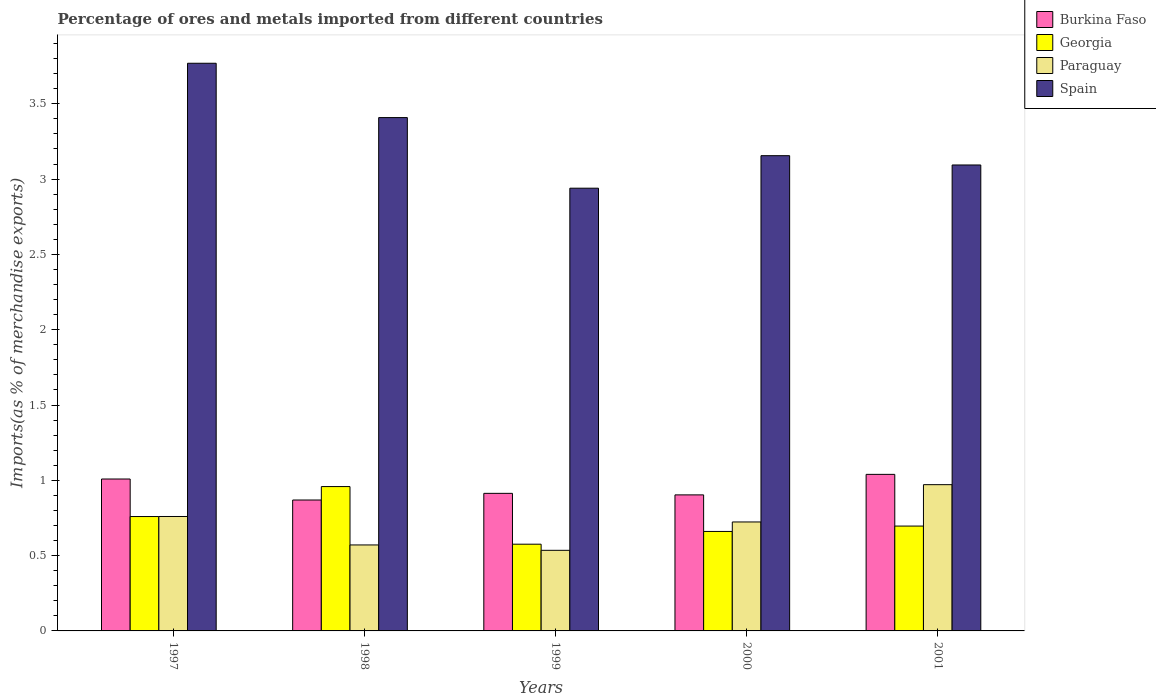How many different coloured bars are there?
Make the answer very short. 4. Are the number of bars per tick equal to the number of legend labels?
Keep it short and to the point. Yes. Are the number of bars on each tick of the X-axis equal?
Make the answer very short. Yes. How many bars are there on the 1st tick from the left?
Keep it short and to the point. 4. What is the label of the 4th group of bars from the left?
Your answer should be compact. 2000. In how many cases, is the number of bars for a given year not equal to the number of legend labels?
Provide a short and direct response. 0. What is the percentage of imports to different countries in Georgia in 1999?
Offer a very short reply. 0.58. Across all years, what is the maximum percentage of imports to different countries in Spain?
Ensure brevity in your answer.  3.77. Across all years, what is the minimum percentage of imports to different countries in Georgia?
Offer a very short reply. 0.58. In which year was the percentage of imports to different countries in Georgia maximum?
Make the answer very short. 1998. What is the total percentage of imports to different countries in Burkina Faso in the graph?
Ensure brevity in your answer.  4.73. What is the difference between the percentage of imports to different countries in Spain in 1998 and that in 2001?
Your response must be concise. 0.31. What is the difference between the percentage of imports to different countries in Burkina Faso in 1998 and the percentage of imports to different countries in Georgia in 2001?
Provide a succinct answer. 0.17. What is the average percentage of imports to different countries in Burkina Faso per year?
Your answer should be very brief. 0.95. In the year 1998, what is the difference between the percentage of imports to different countries in Georgia and percentage of imports to different countries in Paraguay?
Your response must be concise. 0.39. In how many years, is the percentage of imports to different countries in Spain greater than 1.2 %?
Your answer should be compact. 5. What is the ratio of the percentage of imports to different countries in Burkina Faso in 1999 to that in 2001?
Keep it short and to the point. 0.88. Is the percentage of imports to different countries in Paraguay in 1998 less than that in 2001?
Provide a short and direct response. Yes. Is the difference between the percentage of imports to different countries in Georgia in 1997 and 2000 greater than the difference between the percentage of imports to different countries in Paraguay in 1997 and 2000?
Ensure brevity in your answer.  Yes. What is the difference between the highest and the second highest percentage of imports to different countries in Spain?
Ensure brevity in your answer.  0.36. What is the difference between the highest and the lowest percentage of imports to different countries in Spain?
Make the answer very short. 0.83. In how many years, is the percentage of imports to different countries in Paraguay greater than the average percentage of imports to different countries in Paraguay taken over all years?
Keep it short and to the point. 3. Is it the case that in every year, the sum of the percentage of imports to different countries in Spain and percentage of imports to different countries in Georgia is greater than the sum of percentage of imports to different countries in Burkina Faso and percentage of imports to different countries in Paraguay?
Offer a very short reply. Yes. What does the 2nd bar from the left in 1997 represents?
Provide a short and direct response. Georgia. What does the 1st bar from the right in 1998 represents?
Your response must be concise. Spain. What is the difference between two consecutive major ticks on the Y-axis?
Provide a short and direct response. 0.5. Are the values on the major ticks of Y-axis written in scientific E-notation?
Offer a terse response. No. What is the title of the graph?
Give a very brief answer. Percentage of ores and metals imported from different countries. Does "Qatar" appear as one of the legend labels in the graph?
Provide a short and direct response. No. What is the label or title of the Y-axis?
Make the answer very short. Imports(as % of merchandise exports). What is the Imports(as % of merchandise exports) of Burkina Faso in 1997?
Your answer should be compact. 1.01. What is the Imports(as % of merchandise exports) of Georgia in 1997?
Give a very brief answer. 0.76. What is the Imports(as % of merchandise exports) in Paraguay in 1997?
Provide a succinct answer. 0.76. What is the Imports(as % of merchandise exports) in Spain in 1997?
Your response must be concise. 3.77. What is the Imports(as % of merchandise exports) in Burkina Faso in 1998?
Your response must be concise. 0.87. What is the Imports(as % of merchandise exports) in Georgia in 1998?
Your answer should be compact. 0.96. What is the Imports(as % of merchandise exports) of Paraguay in 1998?
Offer a very short reply. 0.57. What is the Imports(as % of merchandise exports) of Spain in 1998?
Ensure brevity in your answer.  3.41. What is the Imports(as % of merchandise exports) in Burkina Faso in 1999?
Your answer should be compact. 0.91. What is the Imports(as % of merchandise exports) in Georgia in 1999?
Keep it short and to the point. 0.58. What is the Imports(as % of merchandise exports) in Paraguay in 1999?
Provide a succinct answer. 0.54. What is the Imports(as % of merchandise exports) in Spain in 1999?
Your answer should be compact. 2.94. What is the Imports(as % of merchandise exports) of Burkina Faso in 2000?
Offer a very short reply. 0.9. What is the Imports(as % of merchandise exports) of Georgia in 2000?
Make the answer very short. 0.66. What is the Imports(as % of merchandise exports) in Paraguay in 2000?
Provide a succinct answer. 0.72. What is the Imports(as % of merchandise exports) in Spain in 2000?
Make the answer very short. 3.16. What is the Imports(as % of merchandise exports) of Burkina Faso in 2001?
Give a very brief answer. 1.04. What is the Imports(as % of merchandise exports) of Georgia in 2001?
Give a very brief answer. 0.7. What is the Imports(as % of merchandise exports) of Paraguay in 2001?
Provide a short and direct response. 0.97. What is the Imports(as % of merchandise exports) in Spain in 2001?
Your answer should be very brief. 3.09. Across all years, what is the maximum Imports(as % of merchandise exports) in Burkina Faso?
Offer a very short reply. 1.04. Across all years, what is the maximum Imports(as % of merchandise exports) of Georgia?
Provide a short and direct response. 0.96. Across all years, what is the maximum Imports(as % of merchandise exports) of Paraguay?
Give a very brief answer. 0.97. Across all years, what is the maximum Imports(as % of merchandise exports) of Spain?
Provide a short and direct response. 3.77. Across all years, what is the minimum Imports(as % of merchandise exports) of Burkina Faso?
Provide a short and direct response. 0.87. Across all years, what is the minimum Imports(as % of merchandise exports) in Georgia?
Ensure brevity in your answer.  0.58. Across all years, what is the minimum Imports(as % of merchandise exports) in Paraguay?
Provide a succinct answer. 0.54. Across all years, what is the minimum Imports(as % of merchandise exports) of Spain?
Provide a short and direct response. 2.94. What is the total Imports(as % of merchandise exports) in Burkina Faso in the graph?
Make the answer very short. 4.73. What is the total Imports(as % of merchandise exports) in Georgia in the graph?
Your answer should be compact. 3.65. What is the total Imports(as % of merchandise exports) of Paraguay in the graph?
Offer a terse response. 3.56. What is the total Imports(as % of merchandise exports) of Spain in the graph?
Offer a very short reply. 16.37. What is the difference between the Imports(as % of merchandise exports) in Burkina Faso in 1997 and that in 1998?
Keep it short and to the point. 0.14. What is the difference between the Imports(as % of merchandise exports) in Georgia in 1997 and that in 1998?
Your response must be concise. -0.2. What is the difference between the Imports(as % of merchandise exports) of Paraguay in 1997 and that in 1998?
Ensure brevity in your answer.  0.19. What is the difference between the Imports(as % of merchandise exports) of Spain in 1997 and that in 1998?
Provide a short and direct response. 0.36. What is the difference between the Imports(as % of merchandise exports) of Burkina Faso in 1997 and that in 1999?
Offer a very short reply. 0.1. What is the difference between the Imports(as % of merchandise exports) in Georgia in 1997 and that in 1999?
Keep it short and to the point. 0.18. What is the difference between the Imports(as % of merchandise exports) in Paraguay in 1997 and that in 1999?
Offer a terse response. 0.22. What is the difference between the Imports(as % of merchandise exports) in Spain in 1997 and that in 1999?
Provide a short and direct response. 0.83. What is the difference between the Imports(as % of merchandise exports) in Burkina Faso in 1997 and that in 2000?
Keep it short and to the point. 0.11. What is the difference between the Imports(as % of merchandise exports) in Georgia in 1997 and that in 2000?
Make the answer very short. 0.1. What is the difference between the Imports(as % of merchandise exports) of Paraguay in 1997 and that in 2000?
Offer a terse response. 0.04. What is the difference between the Imports(as % of merchandise exports) of Spain in 1997 and that in 2000?
Your answer should be very brief. 0.61. What is the difference between the Imports(as % of merchandise exports) in Burkina Faso in 1997 and that in 2001?
Provide a short and direct response. -0.03. What is the difference between the Imports(as % of merchandise exports) of Georgia in 1997 and that in 2001?
Your answer should be compact. 0.06. What is the difference between the Imports(as % of merchandise exports) in Paraguay in 1997 and that in 2001?
Your answer should be compact. -0.21. What is the difference between the Imports(as % of merchandise exports) of Spain in 1997 and that in 2001?
Your answer should be compact. 0.68. What is the difference between the Imports(as % of merchandise exports) of Burkina Faso in 1998 and that in 1999?
Your answer should be compact. -0.04. What is the difference between the Imports(as % of merchandise exports) of Georgia in 1998 and that in 1999?
Keep it short and to the point. 0.38. What is the difference between the Imports(as % of merchandise exports) of Paraguay in 1998 and that in 1999?
Ensure brevity in your answer.  0.04. What is the difference between the Imports(as % of merchandise exports) in Spain in 1998 and that in 1999?
Give a very brief answer. 0.47. What is the difference between the Imports(as % of merchandise exports) in Burkina Faso in 1998 and that in 2000?
Give a very brief answer. -0.03. What is the difference between the Imports(as % of merchandise exports) of Georgia in 1998 and that in 2000?
Your response must be concise. 0.3. What is the difference between the Imports(as % of merchandise exports) in Paraguay in 1998 and that in 2000?
Provide a succinct answer. -0.15. What is the difference between the Imports(as % of merchandise exports) of Spain in 1998 and that in 2000?
Provide a short and direct response. 0.25. What is the difference between the Imports(as % of merchandise exports) in Burkina Faso in 1998 and that in 2001?
Make the answer very short. -0.17. What is the difference between the Imports(as % of merchandise exports) of Georgia in 1998 and that in 2001?
Make the answer very short. 0.26. What is the difference between the Imports(as % of merchandise exports) in Paraguay in 1998 and that in 2001?
Make the answer very short. -0.4. What is the difference between the Imports(as % of merchandise exports) in Spain in 1998 and that in 2001?
Your answer should be compact. 0.31. What is the difference between the Imports(as % of merchandise exports) of Burkina Faso in 1999 and that in 2000?
Your response must be concise. 0.01. What is the difference between the Imports(as % of merchandise exports) in Georgia in 1999 and that in 2000?
Provide a succinct answer. -0.08. What is the difference between the Imports(as % of merchandise exports) of Paraguay in 1999 and that in 2000?
Offer a very short reply. -0.19. What is the difference between the Imports(as % of merchandise exports) of Spain in 1999 and that in 2000?
Give a very brief answer. -0.22. What is the difference between the Imports(as % of merchandise exports) in Burkina Faso in 1999 and that in 2001?
Provide a short and direct response. -0.13. What is the difference between the Imports(as % of merchandise exports) of Georgia in 1999 and that in 2001?
Your answer should be very brief. -0.12. What is the difference between the Imports(as % of merchandise exports) in Paraguay in 1999 and that in 2001?
Give a very brief answer. -0.44. What is the difference between the Imports(as % of merchandise exports) of Spain in 1999 and that in 2001?
Your answer should be compact. -0.15. What is the difference between the Imports(as % of merchandise exports) of Burkina Faso in 2000 and that in 2001?
Your answer should be very brief. -0.14. What is the difference between the Imports(as % of merchandise exports) in Georgia in 2000 and that in 2001?
Give a very brief answer. -0.04. What is the difference between the Imports(as % of merchandise exports) in Paraguay in 2000 and that in 2001?
Provide a succinct answer. -0.25. What is the difference between the Imports(as % of merchandise exports) of Spain in 2000 and that in 2001?
Give a very brief answer. 0.06. What is the difference between the Imports(as % of merchandise exports) of Burkina Faso in 1997 and the Imports(as % of merchandise exports) of Georgia in 1998?
Offer a very short reply. 0.05. What is the difference between the Imports(as % of merchandise exports) of Burkina Faso in 1997 and the Imports(as % of merchandise exports) of Paraguay in 1998?
Offer a very short reply. 0.44. What is the difference between the Imports(as % of merchandise exports) in Burkina Faso in 1997 and the Imports(as % of merchandise exports) in Spain in 1998?
Your answer should be very brief. -2.4. What is the difference between the Imports(as % of merchandise exports) in Georgia in 1997 and the Imports(as % of merchandise exports) in Paraguay in 1998?
Your answer should be very brief. 0.19. What is the difference between the Imports(as % of merchandise exports) of Georgia in 1997 and the Imports(as % of merchandise exports) of Spain in 1998?
Provide a succinct answer. -2.65. What is the difference between the Imports(as % of merchandise exports) in Paraguay in 1997 and the Imports(as % of merchandise exports) in Spain in 1998?
Provide a short and direct response. -2.65. What is the difference between the Imports(as % of merchandise exports) of Burkina Faso in 1997 and the Imports(as % of merchandise exports) of Georgia in 1999?
Offer a terse response. 0.43. What is the difference between the Imports(as % of merchandise exports) in Burkina Faso in 1997 and the Imports(as % of merchandise exports) in Paraguay in 1999?
Give a very brief answer. 0.47. What is the difference between the Imports(as % of merchandise exports) of Burkina Faso in 1997 and the Imports(as % of merchandise exports) of Spain in 1999?
Your answer should be very brief. -1.93. What is the difference between the Imports(as % of merchandise exports) in Georgia in 1997 and the Imports(as % of merchandise exports) in Paraguay in 1999?
Make the answer very short. 0.22. What is the difference between the Imports(as % of merchandise exports) of Georgia in 1997 and the Imports(as % of merchandise exports) of Spain in 1999?
Provide a succinct answer. -2.18. What is the difference between the Imports(as % of merchandise exports) in Paraguay in 1997 and the Imports(as % of merchandise exports) in Spain in 1999?
Keep it short and to the point. -2.18. What is the difference between the Imports(as % of merchandise exports) of Burkina Faso in 1997 and the Imports(as % of merchandise exports) of Georgia in 2000?
Give a very brief answer. 0.35. What is the difference between the Imports(as % of merchandise exports) of Burkina Faso in 1997 and the Imports(as % of merchandise exports) of Paraguay in 2000?
Ensure brevity in your answer.  0.29. What is the difference between the Imports(as % of merchandise exports) in Burkina Faso in 1997 and the Imports(as % of merchandise exports) in Spain in 2000?
Offer a terse response. -2.15. What is the difference between the Imports(as % of merchandise exports) of Georgia in 1997 and the Imports(as % of merchandise exports) of Paraguay in 2000?
Your response must be concise. 0.04. What is the difference between the Imports(as % of merchandise exports) in Georgia in 1997 and the Imports(as % of merchandise exports) in Spain in 2000?
Make the answer very short. -2.4. What is the difference between the Imports(as % of merchandise exports) of Paraguay in 1997 and the Imports(as % of merchandise exports) of Spain in 2000?
Provide a short and direct response. -2.4. What is the difference between the Imports(as % of merchandise exports) of Burkina Faso in 1997 and the Imports(as % of merchandise exports) of Georgia in 2001?
Your answer should be very brief. 0.31. What is the difference between the Imports(as % of merchandise exports) in Burkina Faso in 1997 and the Imports(as % of merchandise exports) in Paraguay in 2001?
Offer a very short reply. 0.04. What is the difference between the Imports(as % of merchandise exports) of Burkina Faso in 1997 and the Imports(as % of merchandise exports) of Spain in 2001?
Offer a terse response. -2.09. What is the difference between the Imports(as % of merchandise exports) in Georgia in 1997 and the Imports(as % of merchandise exports) in Paraguay in 2001?
Offer a terse response. -0.21. What is the difference between the Imports(as % of merchandise exports) in Georgia in 1997 and the Imports(as % of merchandise exports) in Spain in 2001?
Make the answer very short. -2.33. What is the difference between the Imports(as % of merchandise exports) of Paraguay in 1997 and the Imports(as % of merchandise exports) of Spain in 2001?
Make the answer very short. -2.33. What is the difference between the Imports(as % of merchandise exports) in Burkina Faso in 1998 and the Imports(as % of merchandise exports) in Georgia in 1999?
Provide a succinct answer. 0.29. What is the difference between the Imports(as % of merchandise exports) of Burkina Faso in 1998 and the Imports(as % of merchandise exports) of Paraguay in 1999?
Your answer should be very brief. 0.33. What is the difference between the Imports(as % of merchandise exports) of Burkina Faso in 1998 and the Imports(as % of merchandise exports) of Spain in 1999?
Provide a short and direct response. -2.07. What is the difference between the Imports(as % of merchandise exports) of Georgia in 1998 and the Imports(as % of merchandise exports) of Paraguay in 1999?
Offer a terse response. 0.42. What is the difference between the Imports(as % of merchandise exports) in Georgia in 1998 and the Imports(as % of merchandise exports) in Spain in 1999?
Your response must be concise. -1.98. What is the difference between the Imports(as % of merchandise exports) in Paraguay in 1998 and the Imports(as % of merchandise exports) in Spain in 1999?
Your answer should be very brief. -2.37. What is the difference between the Imports(as % of merchandise exports) of Burkina Faso in 1998 and the Imports(as % of merchandise exports) of Georgia in 2000?
Offer a terse response. 0.21. What is the difference between the Imports(as % of merchandise exports) in Burkina Faso in 1998 and the Imports(as % of merchandise exports) in Paraguay in 2000?
Make the answer very short. 0.15. What is the difference between the Imports(as % of merchandise exports) of Burkina Faso in 1998 and the Imports(as % of merchandise exports) of Spain in 2000?
Offer a terse response. -2.29. What is the difference between the Imports(as % of merchandise exports) in Georgia in 1998 and the Imports(as % of merchandise exports) in Paraguay in 2000?
Offer a terse response. 0.23. What is the difference between the Imports(as % of merchandise exports) of Georgia in 1998 and the Imports(as % of merchandise exports) of Spain in 2000?
Your response must be concise. -2.2. What is the difference between the Imports(as % of merchandise exports) of Paraguay in 1998 and the Imports(as % of merchandise exports) of Spain in 2000?
Give a very brief answer. -2.58. What is the difference between the Imports(as % of merchandise exports) of Burkina Faso in 1998 and the Imports(as % of merchandise exports) of Georgia in 2001?
Make the answer very short. 0.17. What is the difference between the Imports(as % of merchandise exports) in Burkina Faso in 1998 and the Imports(as % of merchandise exports) in Paraguay in 2001?
Offer a very short reply. -0.1. What is the difference between the Imports(as % of merchandise exports) in Burkina Faso in 1998 and the Imports(as % of merchandise exports) in Spain in 2001?
Offer a very short reply. -2.22. What is the difference between the Imports(as % of merchandise exports) in Georgia in 1998 and the Imports(as % of merchandise exports) in Paraguay in 2001?
Make the answer very short. -0.01. What is the difference between the Imports(as % of merchandise exports) in Georgia in 1998 and the Imports(as % of merchandise exports) in Spain in 2001?
Offer a very short reply. -2.14. What is the difference between the Imports(as % of merchandise exports) of Paraguay in 1998 and the Imports(as % of merchandise exports) of Spain in 2001?
Provide a succinct answer. -2.52. What is the difference between the Imports(as % of merchandise exports) of Burkina Faso in 1999 and the Imports(as % of merchandise exports) of Georgia in 2000?
Give a very brief answer. 0.25. What is the difference between the Imports(as % of merchandise exports) in Burkina Faso in 1999 and the Imports(as % of merchandise exports) in Paraguay in 2000?
Your answer should be compact. 0.19. What is the difference between the Imports(as % of merchandise exports) of Burkina Faso in 1999 and the Imports(as % of merchandise exports) of Spain in 2000?
Offer a very short reply. -2.24. What is the difference between the Imports(as % of merchandise exports) of Georgia in 1999 and the Imports(as % of merchandise exports) of Paraguay in 2000?
Ensure brevity in your answer.  -0.15. What is the difference between the Imports(as % of merchandise exports) of Georgia in 1999 and the Imports(as % of merchandise exports) of Spain in 2000?
Your answer should be very brief. -2.58. What is the difference between the Imports(as % of merchandise exports) of Paraguay in 1999 and the Imports(as % of merchandise exports) of Spain in 2000?
Ensure brevity in your answer.  -2.62. What is the difference between the Imports(as % of merchandise exports) in Burkina Faso in 1999 and the Imports(as % of merchandise exports) in Georgia in 2001?
Provide a succinct answer. 0.22. What is the difference between the Imports(as % of merchandise exports) in Burkina Faso in 1999 and the Imports(as % of merchandise exports) in Paraguay in 2001?
Provide a succinct answer. -0.06. What is the difference between the Imports(as % of merchandise exports) in Burkina Faso in 1999 and the Imports(as % of merchandise exports) in Spain in 2001?
Provide a succinct answer. -2.18. What is the difference between the Imports(as % of merchandise exports) in Georgia in 1999 and the Imports(as % of merchandise exports) in Paraguay in 2001?
Offer a terse response. -0.4. What is the difference between the Imports(as % of merchandise exports) of Georgia in 1999 and the Imports(as % of merchandise exports) of Spain in 2001?
Provide a succinct answer. -2.52. What is the difference between the Imports(as % of merchandise exports) in Paraguay in 1999 and the Imports(as % of merchandise exports) in Spain in 2001?
Make the answer very short. -2.56. What is the difference between the Imports(as % of merchandise exports) in Burkina Faso in 2000 and the Imports(as % of merchandise exports) in Georgia in 2001?
Keep it short and to the point. 0.21. What is the difference between the Imports(as % of merchandise exports) of Burkina Faso in 2000 and the Imports(as % of merchandise exports) of Paraguay in 2001?
Offer a very short reply. -0.07. What is the difference between the Imports(as % of merchandise exports) in Burkina Faso in 2000 and the Imports(as % of merchandise exports) in Spain in 2001?
Offer a terse response. -2.19. What is the difference between the Imports(as % of merchandise exports) in Georgia in 2000 and the Imports(as % of merchandise exports) in Paraguay in 2001?
Make the answer very short. -0.31. What is the difference between the Imports(as % of merchandise exports) of Georgia in 2000 and the Imports(as % of merchandise exports) of Spain in 2001?
Your answer should be very brief. -2.43. What is the difference between the Imports(as % of merchandise exports) of Paraguay in 2000 and the Imports(as % of merchandise exports) of Spain in 2001?
Make the answer very short. -2.37. What is the average Imports(as % of merchandise exports) in Burkina Faso per year?
Offer a terse response. 0.95. What is the average Imports(as % of merchandise exports) in Georgia per year?
Provide a succinct answer. 0.73. What is the average Imports(as % of merchandise exports) in Paraguay per year?
Give a very brief answer. 0.71. What is the average Imports(as % of merchandise exports) in Spain per year?
Provide a succinct answer. 3.27. In the year 1997, what is the difference between the Imports(as % of merchandise exports) in Burkina Faso and Imports(as % of merchandise exports) in Georgia?
Your answer should be very brief. 0.25. In the year 1997, what is the difference between the Imports(as % of merchandise exports) of Burkina Faso and Imports(as % of merchandise exports) of Paraguay?
Ensure brevity in your answer.  0.25. In the year 1997, what is the difference between the Imports(as % of merchandise exports) in Burkina Faso and Imports(as % of merchandise exports) in Spain?
Ensure brevity in your answer.  -2.76. In the year 1997, what is the difference between the Imports(as % of merchandise exports) in Georgia and Imports(as % of merchandise exports) in Paraguay?
Offer a very short reply. -0. In the year 1997, what is the difference between the Imports(as % of merchandise exports) in Georgia and Imports(as % of merchandise exports) in Spain?
Provide a succinct answer. -3.01. In the year 1997, what is the difference between the Imports(as % of merchandise exports) in Paraguay and Imports(as % of merchandise exports) in Spain?
Make the answer very short. -3.01. In the year 1998, what is the difference between the Imports(as % of merchandise exports) of Burkina Faso and Imports(as % of merchandise exports) of Georgia?
Your response must be concise. -0.09. In the year 1998, what is the difference between the Imports(as % of merchandise exports) of Burkina Faso and Imports(as % of merchandise exports) of Paraguay?
Offer a very short reply. 0.3. In the year 1998, what is the difference between the Imports(as % of merchandise exports) of Burkina Faso and Imports(as % of merchandise exports) of Spain?
Give a very brief answer. -2.54. In the year 1998, what is the difference between the Imports(as % of merchandise exports) in Georgia and Imports(as % of merchandise exports) in Paraguay?
Ensure brevity in your answer.  0.39. In the year 1998, what is the difference between the Imports(as % of merchandise exports) in Georgia and Imports(as % of merchandise exports) in Spain?
Your answer should be compact. -2.45. In the year 1998, what is the difference between the Imports(as % of merchandise exports) of Paraguay and Imports(as % of merchandise exports) of Spain?
Offer a very short reply. -2.84. In the year 1999, what is the difference between the Imports(as % of merchandise exports) in Burkina Faso and Imports(as % of merchandise exports) in Georgia?
Your response must be concise. 0.34. In the year 1999, what is the difference between the Imports(as % of merchandise exports) in Burkina Faso and Imports(as % of merchandise exports) in Paraguay?
Ensure brevity in your answer.  0.38. In the year 1999, what is the difference between the Imports(as % of merchandise exports) in Burkina Faso and Imports(as % of merchandise exports) in Spain?
Make the answer very short. -2.03. In the year 1999, what is the difference between the Imports(as % of merchandise exports) of Georgia and Imports(as % of merchandise exports) of Paraguay?
Your answer should be compact. 0.04. In the year 1999, what is the difference between the Imports(as % of merchandise exports) in Georgia and Imports(as % of merchandise exports) in Spain?
Provide a short and direct response. -2.36. In the year 1999, what is the difference between the Imports(as % of merchandise exports) of Paraguay and Imports(as % of merchandise exports) of Spain?
Your answer should be compact. -2.4. In the year 2000, what is the difference between the Imports(as % of merchandise exports) of Burkina Faso and Imports(as % of merchandise exports) of Georgia?
Provide a short and direct response. 0.24. In the year 2000, what is the difference between the Imports(as % of merchandise exports) of Burkina Faso and Imports(as % of merchandise exports) of Paraguay?
Your answer should be compact. 0.18. In the year 2000, what is the difference between the Imports(as % of merchandise exports) in Burkina Faso and Imports(as % of merchandise exports) in Spain?
Provide a succinct answer. -2.25. In the year 2000, what is the difference between the Imports(as % of merchandise exports) of Georgia and Imports(as % of merchandise exports) of Paraguay?
Make the answer very short. -0.06. In the year 2000, what is the difference between the Imports(as % of merchandise exports) in Georgia and Imports(as % of merchandise exports) in Spain?
Provide a short and direct response. -2.49. In the year 2000, what is the difference between the Imports(as % of merchandise exports) of Paraguay and Imports(as % of merchandise exports) of Spain?
Give a very brief answer. -2.43. In the year 2001, what is the difference between the Imports(as % of merchandise exports) of Burkina Faso and Imports(as % of merchandise exports) of Georgia?
Give a very brief answer. 0.34. In the year 2001, what is the difference between the Imports(as % of merchandise exports) of Burkina Faso and Imports(as % of merchandise exports) of Paraguay?
Provide a short and direct response. 0.07. In the year 2001, what is the difference between the Imports(as % of merchandise exports) of Burkina Faso and Imports(as % of merchandise exports) of Spain?
Provide a short and direct response. -2.05. In the year 2001, what is the difference between the Imports(as % of merchandise exports) in Georgia and Imports(as % of merchandise exports) in Paraguay?
Provide a short and direct response. -0.27. In the year 2001, what is the difference between the Imports(as % of merchandise exports) of Georgia and Imports(as % of merchandise exports) of Spain?
Provide a short and direct response. -2.4. In the year 2001, what is the difference between the Imports(as % of merchandise exports) of Paraguay and Imports(as % of merchandise exports) of Spain?
Offer a terse response. -2.12. What is the ratio of the Imports(as % of merchandise exports) in Burkina Faso in 1997 to that in 1998?
Ensure brevity in your answer.  1.16. What is the ratio of the Imports(as % of merchandise exports) in Georgia in 1997 to that in 1998?
Your answer should be very brief. 0.79. What is the ratio of the Imports(as % of merchandise exports) in Paraguay in 1997 to that in 1998?
Provide a short and direct response. 1.33. What is the ratio of the Imports(as % of merchandise exports) in Spain in 1997 to that in 1998?
Ensure brevity in your answer.  1.11. What is the ratio of the Imports(as % of merchandise exports) in Burkina Faso in 1997 to that in 1999?
Make the answer very short. 1.1. What is the ratio of the Imports(as % of merchandise exports) of Georgia in 1997 to that in 1999?
Give a very brief answer. 1.32. What is the ratio of the Imports(as % of merchandise exports) in Paraguay in 1997 to that in 1999?
Offer a very short reply. 1.42. What is the ratio of the Imports(as % of merchandise exports) of Spain in 1997 to that in 1999?
Ensure brevity in your answer.  1.28. What is the ratio of the Imports(as % of merchandise exports) in Burkina Faso in 1997 to that in 2000?
Give a very brief answer. 1.12. What is the ratio of the Imports(as % of merchandise exports) of Georgia in 1997 to that in 2000?
Provide a succinct answer. 1.15. What is the ratio of the Imports(as % of merchandise exports) of Paraguay in 1997 to that in 2000?
Offer a very short reply. 1.05. What is the ratio of the Imports(as % of merchandise exports) of Spain in 1997 to that in 2000?
Give a very brief answer. 1.19. What is the ratio of the Imports(as % of merchandise exports) of Burkina Faso in 1997 to that in 2001?
Offer a very short reply. 0.97. What is the ratio of the Imports(as % of merchandise exports) of Paraguay in 1997 to that in 2001?
Ensure brevity in your answer.  0.78. What is the ratio of the Imports(as % of merchandise exports) of Spain in 1997 to that in 2001?
Offer a terse response. 1.22. What is the ratio of the Imports(as % of merchandise exports) in Burkina Faso in 1998 to that in 1999?
Offer a terse response. 0.95. What is the ratio of the Imports(as % of merchandise exports) of Georgia in 1998 to that in 1999?
Offer a terse response. 1.66. What is the ratio of the Imports(as % of merchandise exports) in Paraguay in 1998 to that in 1999?
Your answer should be compact. 1.07. What is the ratio of the Imports(as % of merchandise exports) in Spain in 1998 to that in 1999?
Keep it short and to the point. 1.16. What is the ratio of the Imports(as % of merchandise exports) of Burkina Faso in 1998 to that in 2000?
Ensure brevity in your answer.  0.96. What is the ratio of the Imports(as % of merchandise exports) of Georgia in 1998 to that in 2000?
Your answer should be compact. 1.45. What is the ratio of the Imports(as % of merchandise exports) of Paraguay in 1998 to that in 2000?
Offer a very short reply. 0.79. What is the ratio of the Imports(as % of merchandise exports) in Spain in 1998 to that in 2000?
Your response must be concise. 1.08. What is the ratio of the Imports(as % of merchandise exports) in Burkina Faso in 1998 to that in 2001?
Provide a succinct answer. 0.84. What is the ratio of the Imports(as % of merchandise exports) of Georgia in 1998 to that in 2001?
Make the answer very short. 1.38. What is the ratio of the Imports(as % of merchandise exports) in Paraguay in 1998 to that in 2001?
Your response must be concise. 0.59. What is the ratio of the Imports(as % of merchandise exports) of Spain in 1998 to that in 2001?
Keep it short and to the point. 1.1. What is the ratio of the Imports(as % of merchandise exports) of Burkina Faso in 1999 to that in 2000?
Offer a very short reply. 1.01. What is the ratio of the Imports(as % of merchandise exports) of Georgia in 1999 to that in 2000?
Your response must be concise. 0.87. What is the ratio of the Imports(as % of merchandise exports) of Paraguay in 1999 to that in 2000?
Your answer should be compact. 0.74. What is the ratio of the Imports(as % of merchandise exports) in Spain in 1999 to that in 2000?
Your answer should be very brief. 0.93. What is the ratio of the Imports(as % of merchandise exports) in Burkina Faso in 1999 to that in 2001?
Offer a very short reply. 0.88. What is the ratio of the Imports(as % of merchandise exports) in Georgia in 1999 to that in 2001?
Your answer should be compact. 0.83. What is the ratio of the Imports(as % of merchandise exports) in Paraguay in 1999 to that in 2001?
Provide a succinct answer. 0.55. What is the ratio of the Imports(as % of merchandise exports) of Spain in 1999 to that in 2001?
Offer a terse response. 0.95. What is the ratio of the Imports(as % of merchandise exports) of Burkina Faso in 2000 to that in 2001?
Offer a very short reply. 0.87. What is the ratio of the Imports(as % of merchandise exports) of Georgia in 2000 to that in 2001?
Offer a very short reply. 0.95. What is the ratio of the Imports(as % of merchandise exports) in Paraguay in 2000 to that in 2001?
Your response must be concise. 0.74. What is the difference between the highest and the second highest Imports(as % of merchandise exports) in Burkina Faso?
Your response must be concise. 0.03. What is the difference between the highest and the second highest Imports(as % of merchandise exports) of Georgia?
Give a very brief answer. 0.2. What is the difference between the highest and the second highest Imports(as % of merchandise exports) in Paraguay?
Offer a very short reply. 0.21. What is the difference between the highest and the second highest Imports(as % of merchandise exports) of Spain?
Offer a terse response. 0.36. What is the difference between the highest and the lowest Imports(as % of merchandise exports) of Burkina Faso?
Your answer should be compact. 0.17. What is the difference between the highest and the lowest Imports(as % of merchandise exports) of Georgia?
Ensure brevity in your answer.  0.38. What is the difference between the highest and the lowest Imports(as % of merchandise exports) in Paraguay?
Offer a terse response. 0.44. What is the difference between the highest and the lowest Imports(as % of merchandise exports) of Spain?
Your answer should be very brief. 0.83. 